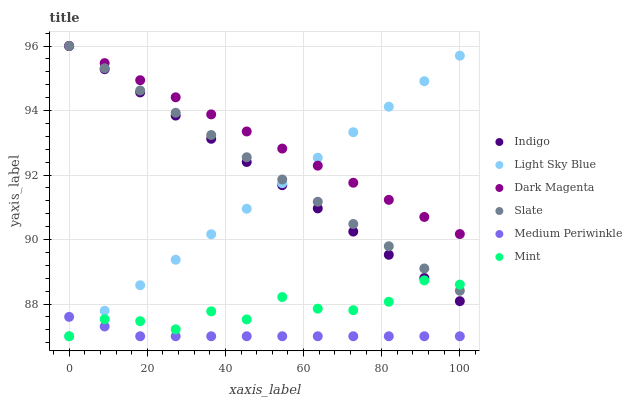Does Medium Periwinkle have the minimum area under the curve?
Answer yes or no. Yes. Does Dark Magenta have the maximum area under the curve?
Answer yes or no. Yes. Does Slate have the minimum area under the curve?
Answer yes or no. No. Does Slate have the maximum area under the curve?
Answer yes or no. No. Is Dark Magenta the smoothest?
Answer yes or no. Yes. Is Mint the roughest?
Answer yes or no. Yes. Is Slate the smoothest?
Answer yes or no. No. Is Slate the roughest?
Answer yes or no. No. Does Medium Periwinkle have the lowest value?
Answer yes or no. Yes. Does Slate have the lowest value?
Answer yes or no. No. Does Slate have the highest value?
Answer yes or no. Yes. Does Medium Periwinkle have the highest value?
Answer yes or no. No. Is Medium Periwinkle less than Dark Magenta?
Answer yes or no. Yes. Is Dark Magenta greater than Mint?
Answer yes or no. Yes. Does Medium Periwinkle intersect Mint?
Answer yes or no. Yes. Is Medium Periwinkle less than Mint?
Answer yes or no. No. Is Medium Periwinkle greater than Mint?
Answer yes or no. No. Does Medium Periwinkle intersect Dark Magenta?
Answer yes or no. No. 